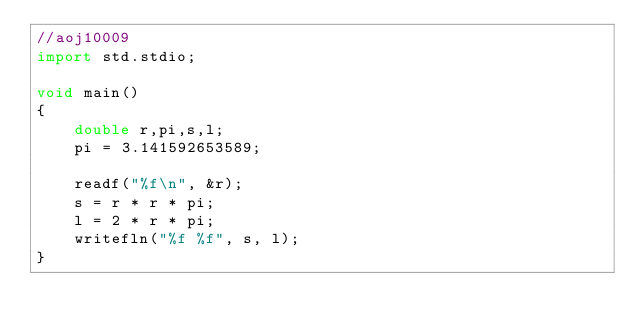<code> <loc_0><loc_0><loc_500><loc_500><_D_>//aoj10009
import std.stdio;

void main()
{
    double r,pi,s,l;
    pi = 3.141592653589;
    
    readf("%f\n", &r);
    s = r * r * pi;
    l = 2 * r * pi;
    writefln("%f %f", s, l);
}</code> 